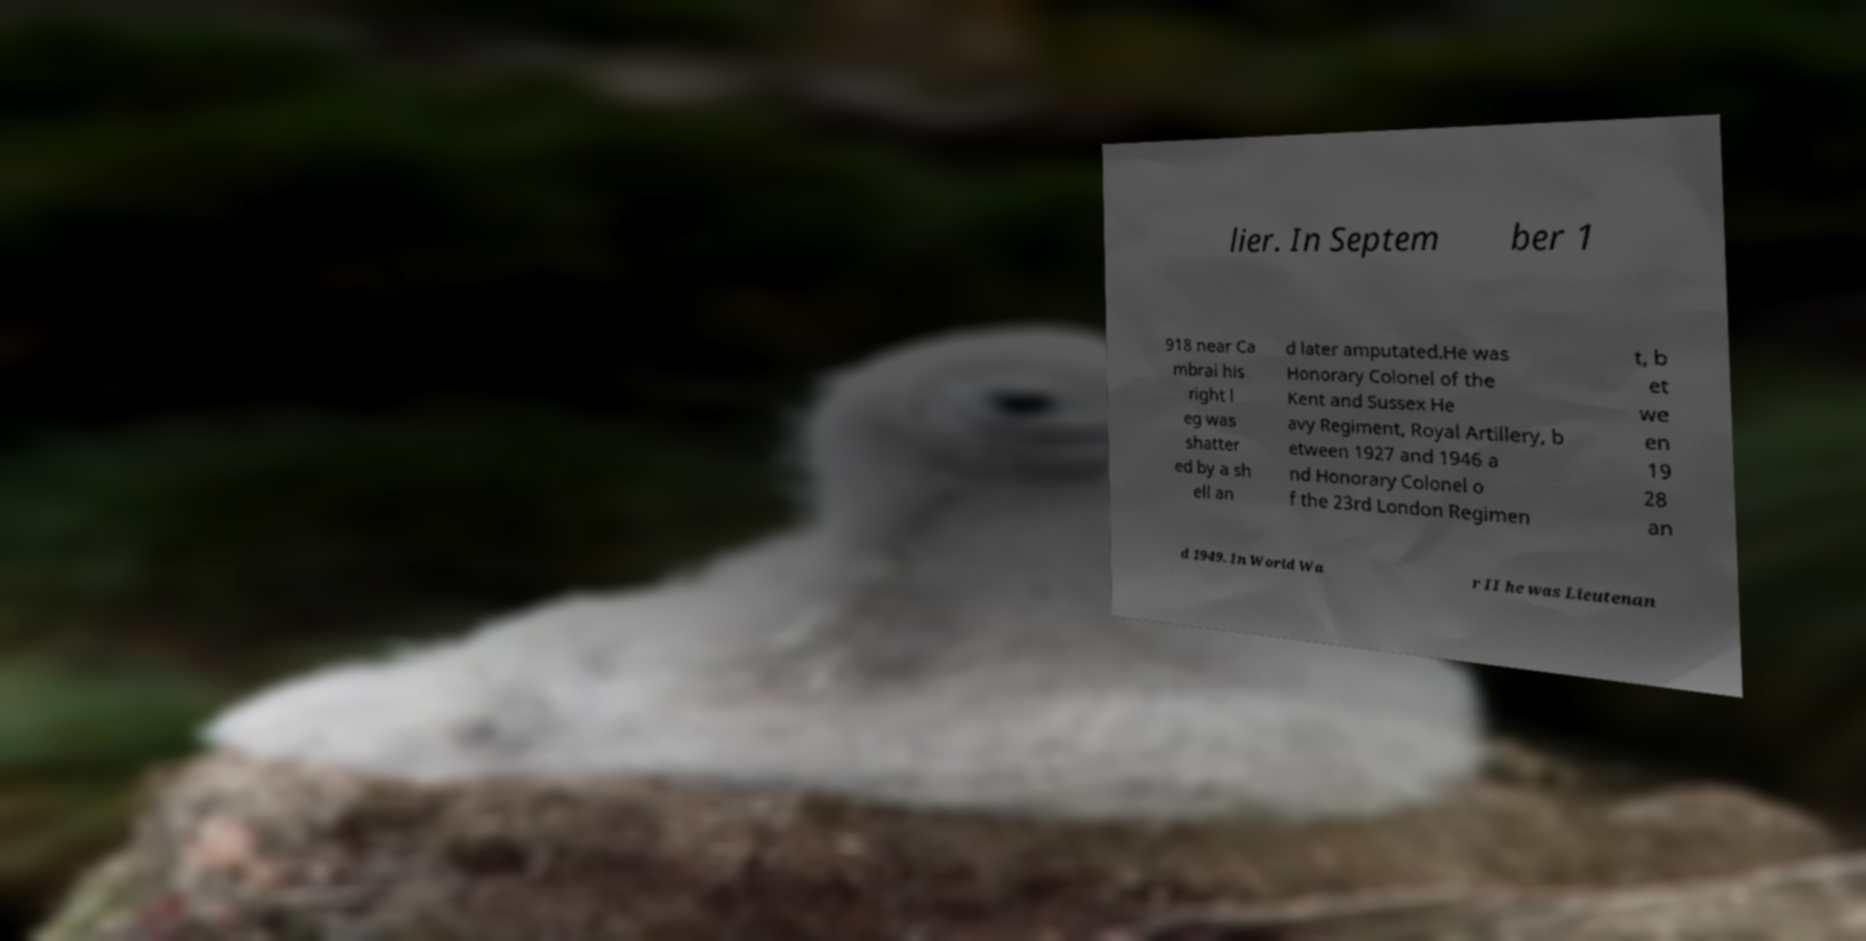There's text embedded in this image that I need extracted. Can you transcribe it verbatim? lier. In Septem ber 1 918 near Ca mbrai his right l eg was shatter ed by a sh ell an d later amputated.He was Honorary Colonel of the Kent and Sussex He avy Regiment, Royal Artillery, b etween 1927 and 1946 a nd Honorary Colonel o f the 23rd London Regimen t, b et we en 19 28 an d 1949. In World Wa r II he was Lieutenan 